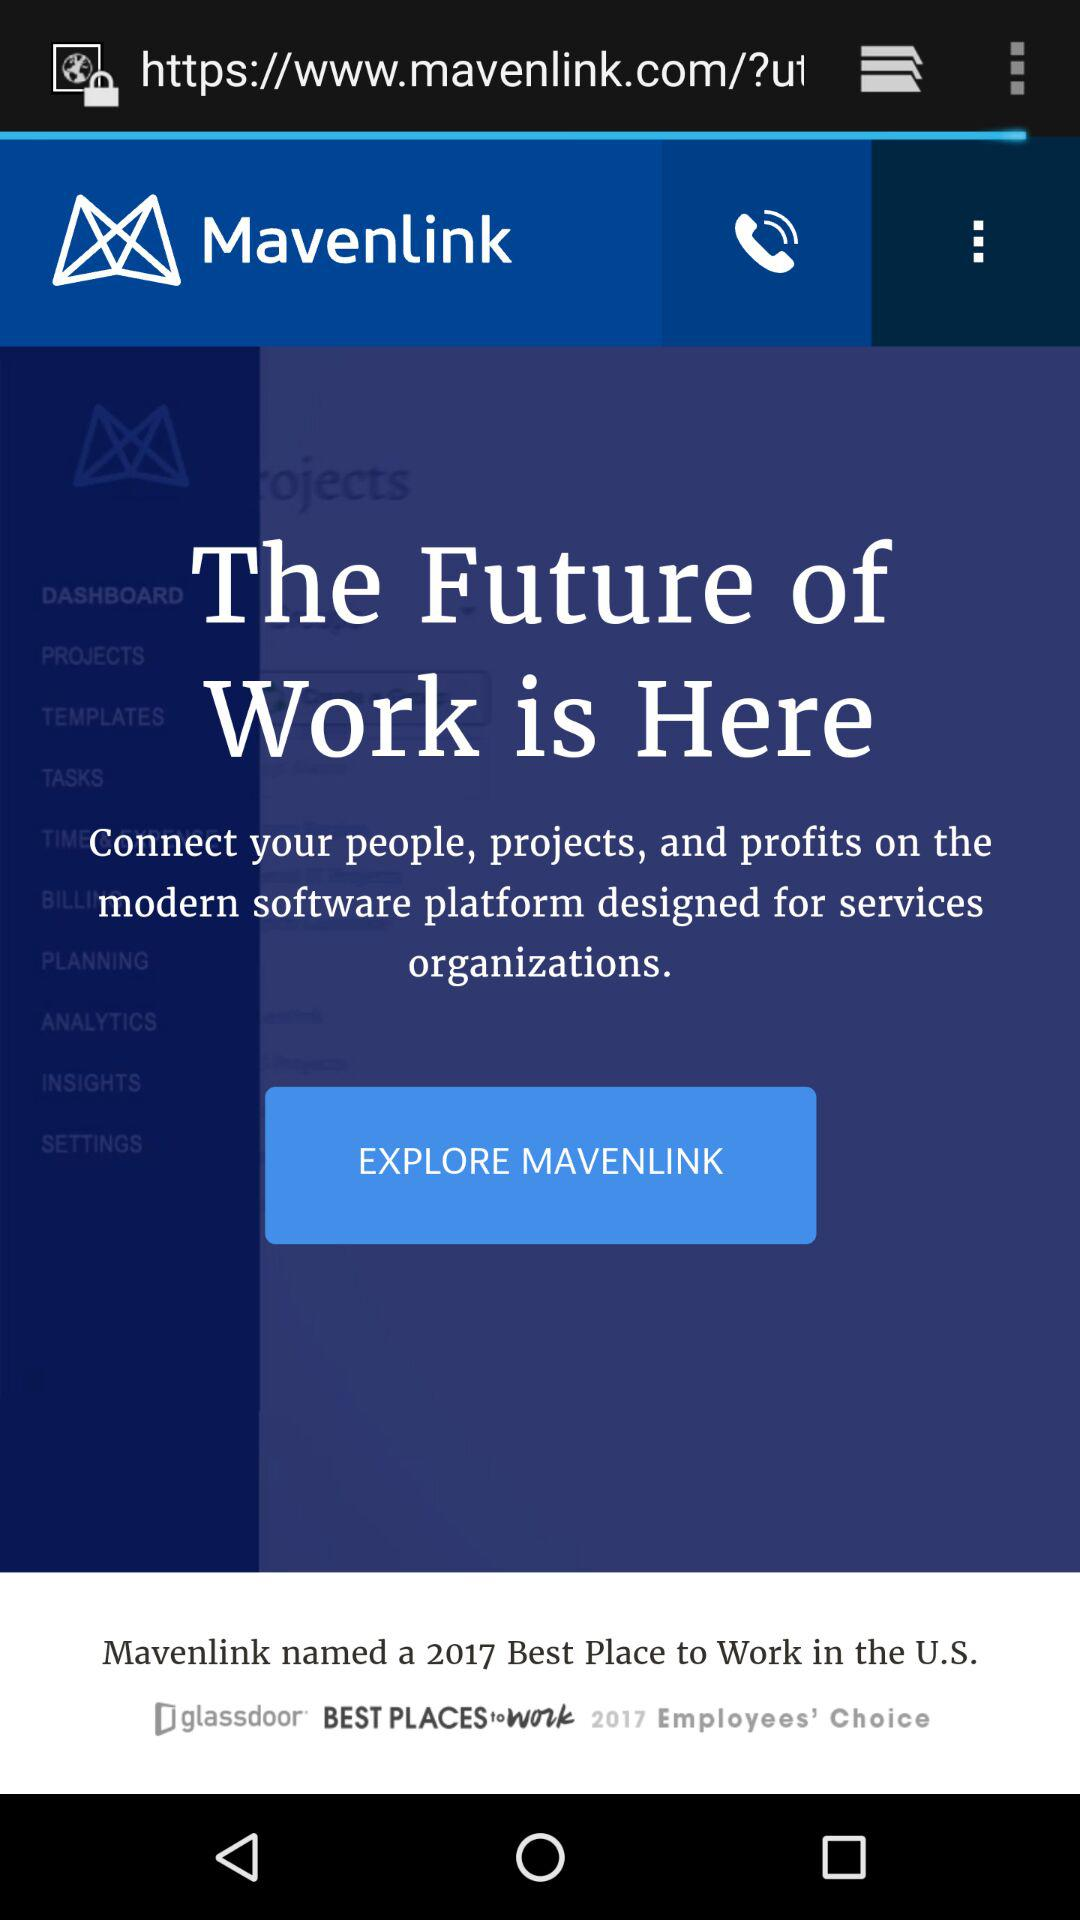When was "MAVENLINK" founded?
When the provided information is insufficient, respond with <no answer>. <no answer> 